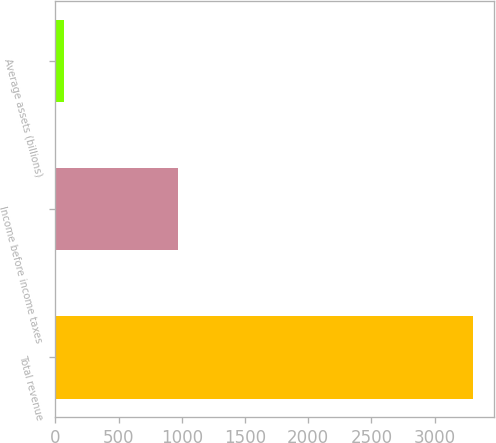Convert chart to OTSL. <chart><loc_0><loc_0><loc_500><loc_500><bar_chart><fcel>Total revenue<fcel>Income before income taxes<fcel>Average assets (billions)<nl><fcel>3306<fcel>969<fcel>69.5<nl></chart> 